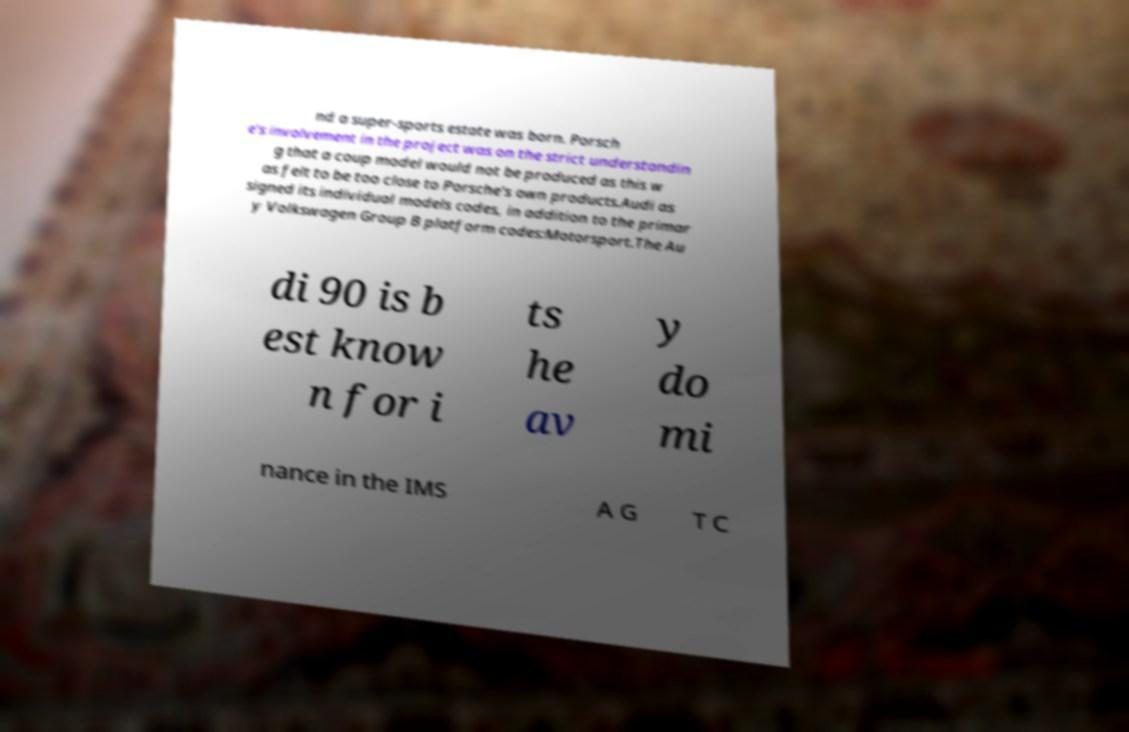Could you extract and type out the text from this image? nd a super-sports estate was born. Porsch e's involvement in the project was on the strict understandin g that a coup model would not be produced as this w as felt to be too close to Porsche's own products.Audi as signed its individual models codes, in addition to the primar y Volkswagen Group B platform codes:Motorsport.The Au di 90 is b est know n for i ts he av y do mi nance in the IMS A G T C 